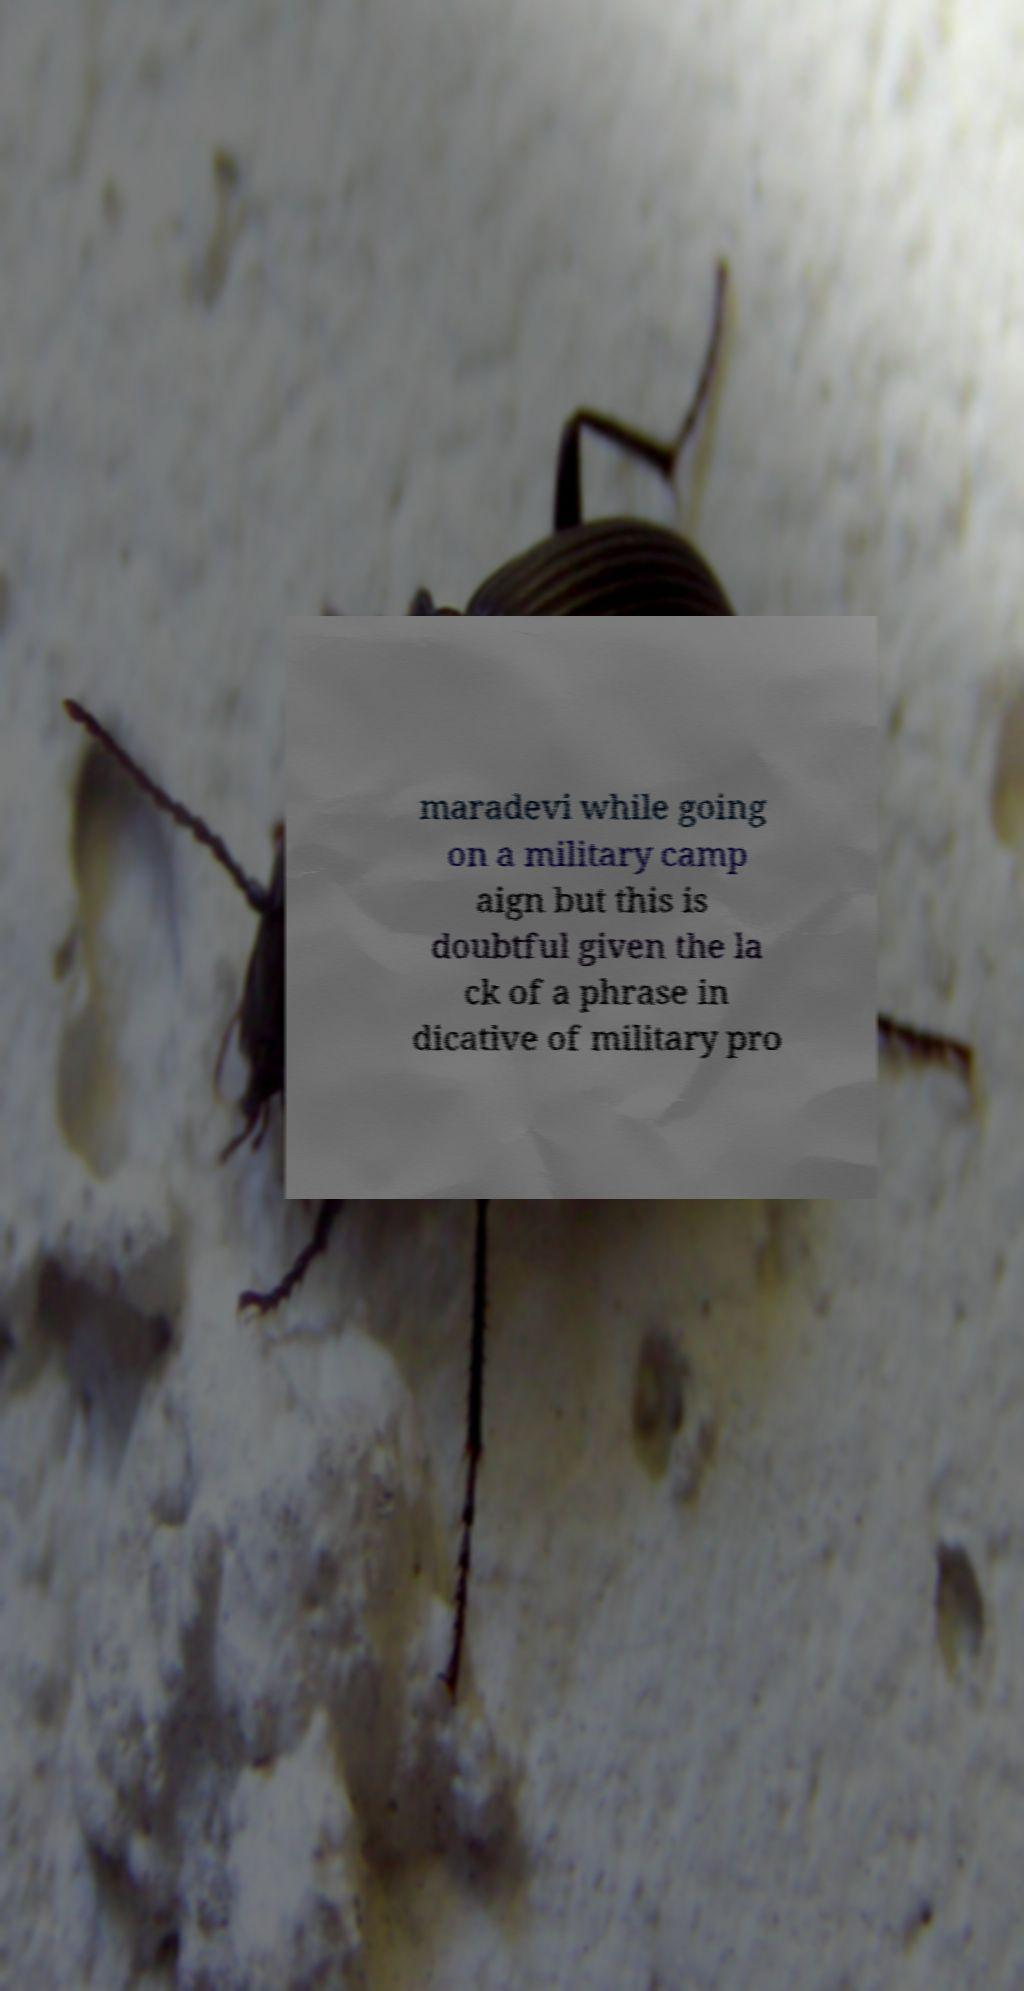Could you extract and type out the text from this image? maradevi while going on a military camp aign but this is doubtful given the la ck of a phrase in dicative of military pro 